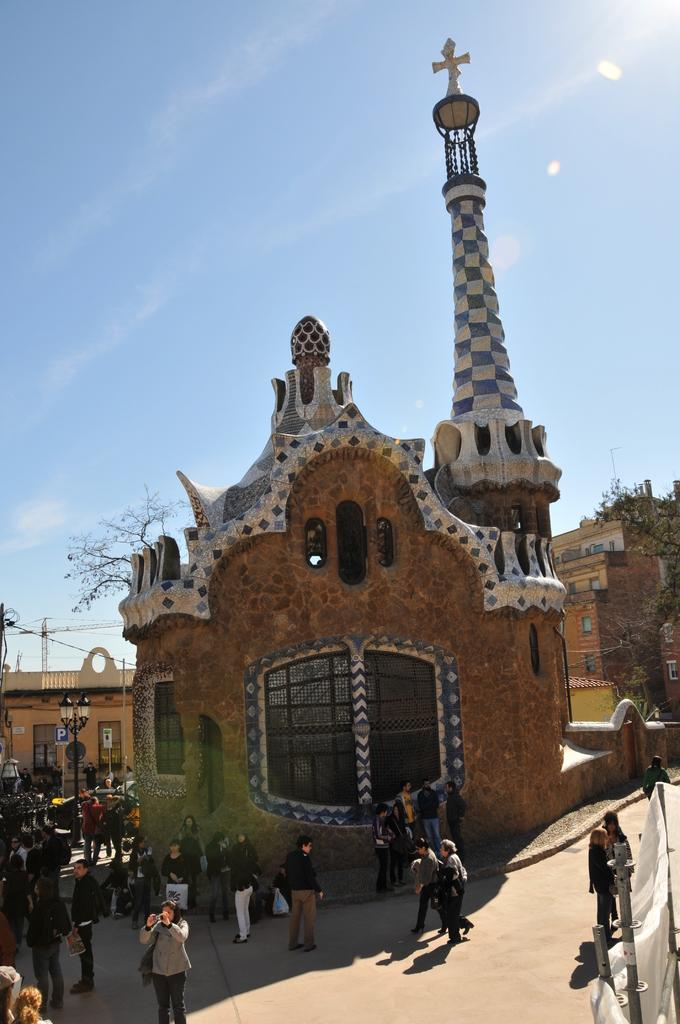Who or what can be seen in the image? There are people in the image. What objects are present in the image? There are poles, cloth, boards, and trees in the image. What type of structures are visible in the image? There are buildings in the image. What can be seen in the background of the image? The sky is visible in the background of the image. What type of meal is being prepared on the net in the image? There is no net or meal preparation present in the image. 